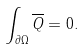<formula> <loc_0><loc_0><loc_500><loc_500>\int _ { \partial \Omega } \overline { Q } = 0 .</formula> 